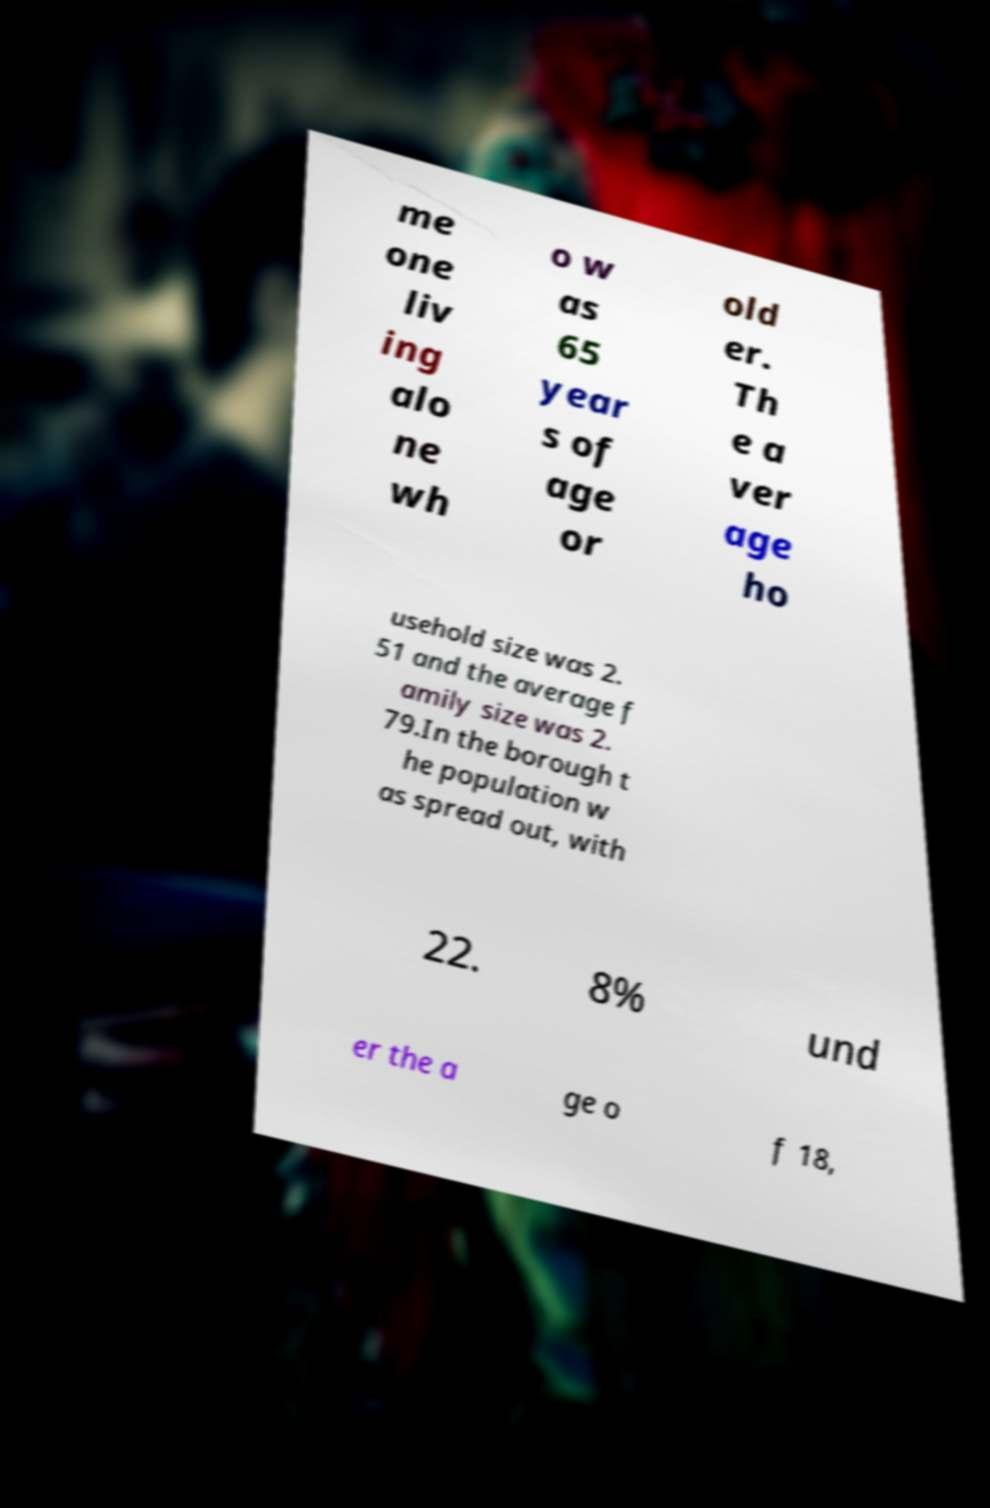Can you read and provide the text displayed in the image?This photo seems to have some interesting text. Can you extract and type it out for me? me one liv ing alo ne wh o w as 65 year s of age or old er. Th e a ver age ho usehold size was 2. 51 and the average f amily size was 2. 79.In the borough t he population w as spread out, with 22. 8% und er the a ge o f 18, 